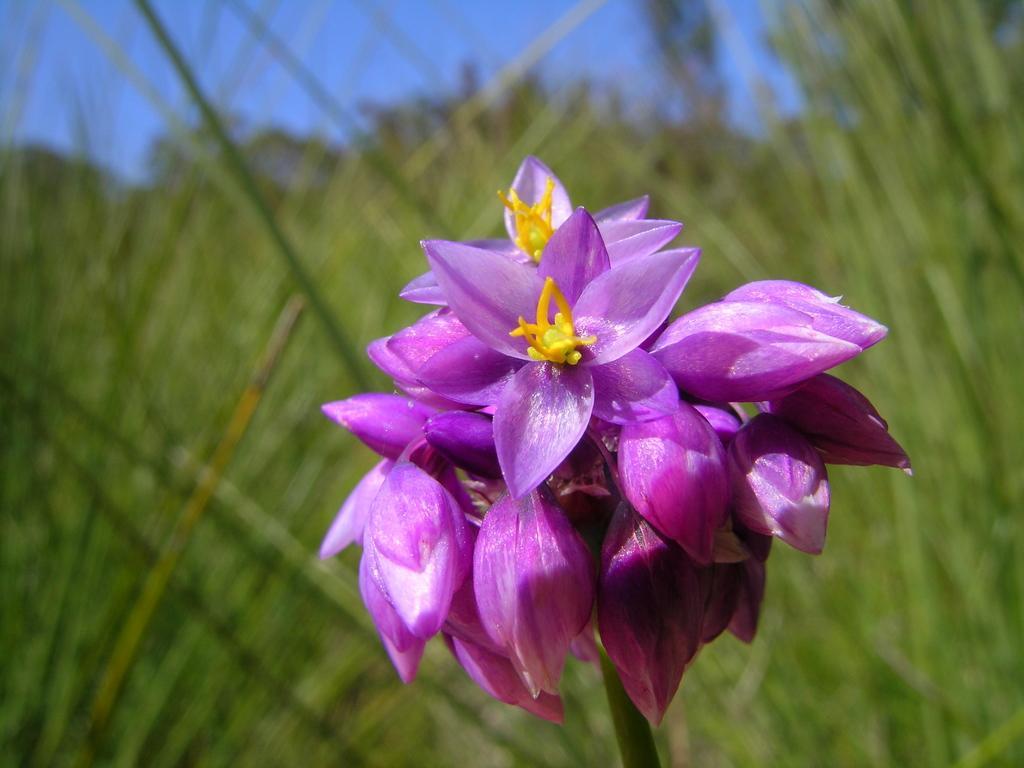Describe this image in one or two sentences. In the image in the center,we can see one flower,which is in pink color. In the background we can see the sky and grass. 